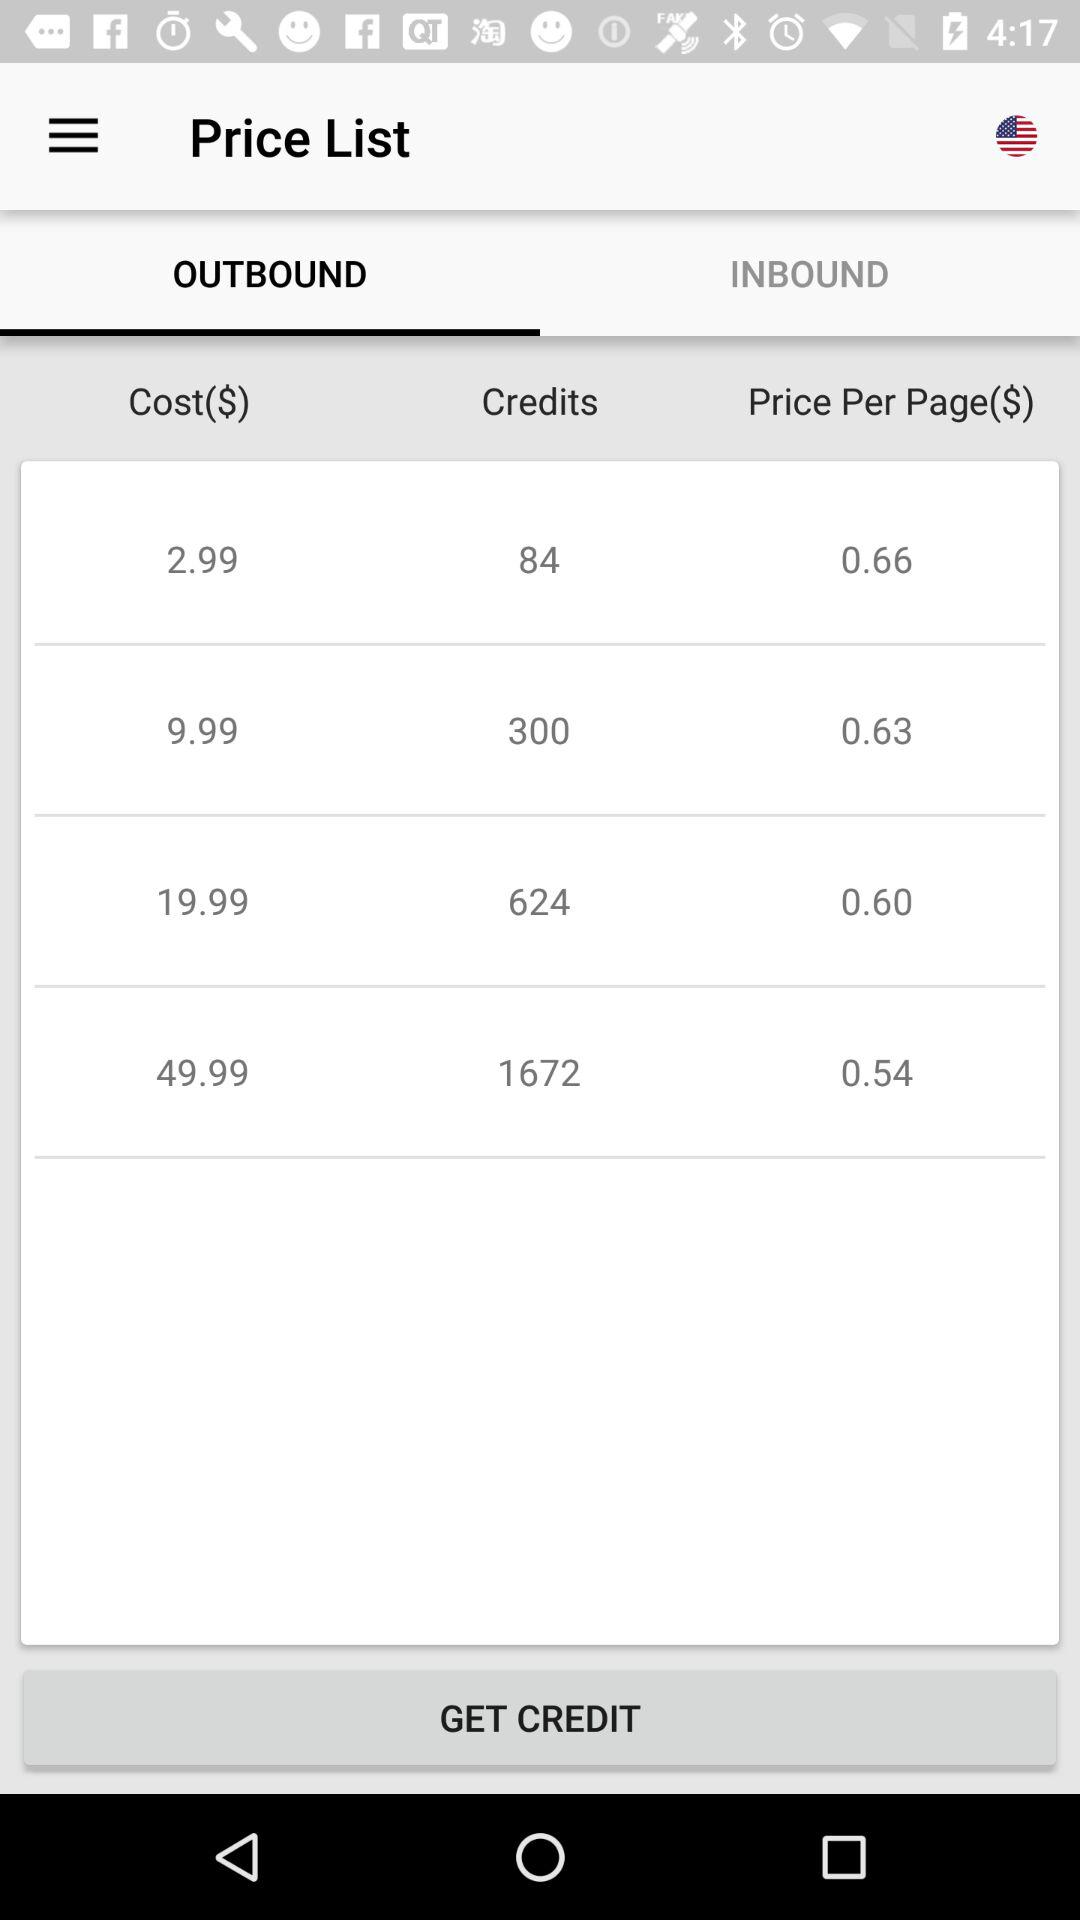What is the cost of 84 credits? The cost of 84 credits is $2.99. 